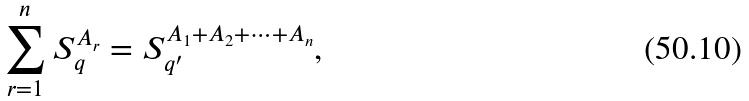Convert formula to latex. <formula><loc_0><loc_0><loc_500><loc_500>\sum _ { r = 1 } ^ { n } S _ { q } ^ { A _ { r } } = S _ { q ^ { \prime } } ^ { A _ { 1 } + A _ { 2 } + \dots + A _ { n } } ,</formula> 